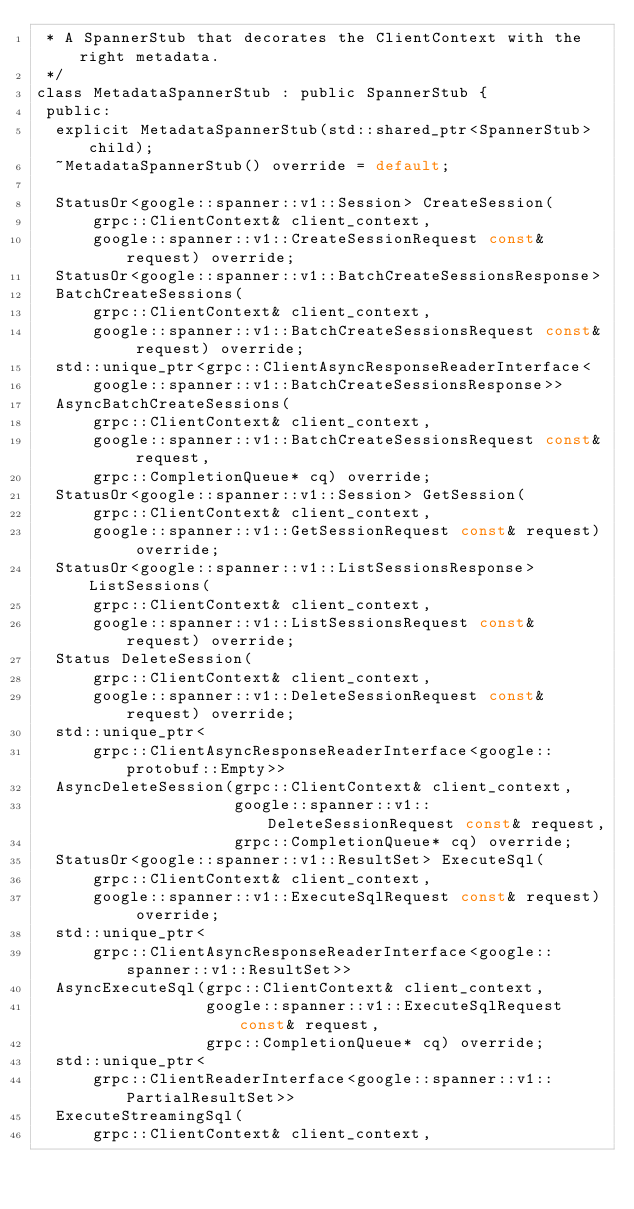<code> <loc_0><loc_0><loc_500><loc_500><_C_> * A SpannerStub that decorates the ClientContext with the right metadata.
 */
class MetadataSpannerStub : public SpannerStub {
 public:
  explicit MetadataSpannerStub(std::shared_ptr<SpannerStub> child);
  ~MetadataSpannerStub() override = default;

  StatusOr<google::spanner::v1::Session> CreateSession(
      grpc::ClientContext& client_context,
      google::spanner::v1::CreateSessionRequest const& request) override;
  StatusOr<google::spanner::v1::BatchCreateSessionsResponse>
  BatchCreateSessions(
      grpc::ClientContext& client_context,
      google::spanner::v1::BatchCreateSessionsRequest const& request) override;
  std::unique_ptr<grpc::ClientAsyncResponseReaderInterface<
      google::spanner::v1::BatchCreateSessionsResponse>>
  AsyncBatchCreateSessions(
      grpc::ClientContext& client_context,
      google::spanner::v1::BatchCreateSessionsRequest const& request,
      grpc::CompletionQueue* cq) override;
  StatusOr<google::spanner::v1::Session> GetSession(
      grpc::ClientContext& client_context,
      google::spanner::v1::GetSessionRequest const& request) override;
  StatusOr<google::spanner::v1::ListSessionsResponse> ListSessions(
      grpc::ClientContext& client_context,
      google::spanner::v1::ListSessionsRequest const& request) override;
  Status DeleteSession(
      grpc::ClientContext& client_context,
      google::spanner::v1::DeleteSessionRequest const& request) override;
  std::unique_ptr<
      grpc::ClientAsyncResponseReaderInterface<google::protobuf::Empty>>
  AsyncDeleteSession(grpc::ClientContext& client_context,
                     google::spanner::v1::DeleteSessionRequest const& request,
                     grpc::CompletionQueue* cq) override;
  StatusOr<google::spanner::v1::ResultSet> ExecuteSql(
      grpc::ClientContext& client_context,
      google::spanner::v1::ExecuteSqlRequest const& request) override;
  std::unique_ptr<
      grpc::ClientAsyncResponseReaderInterface<google::spanner::v1::ResultSet>>
  AsyncExecuteSql(grpc::ClientContext& client_context,
                  google::spanner::v1::ExecuteSqlRequest const& request,
                  grpc::CompletionQueue* cq) override;
  std::unique_ptr<
      grpc::ClientReaderInterface<google::spanner::v1::PartialResultSet>>
  ExecuteStreamingSql(
      grpc::ClientContext& client_context,</code> 